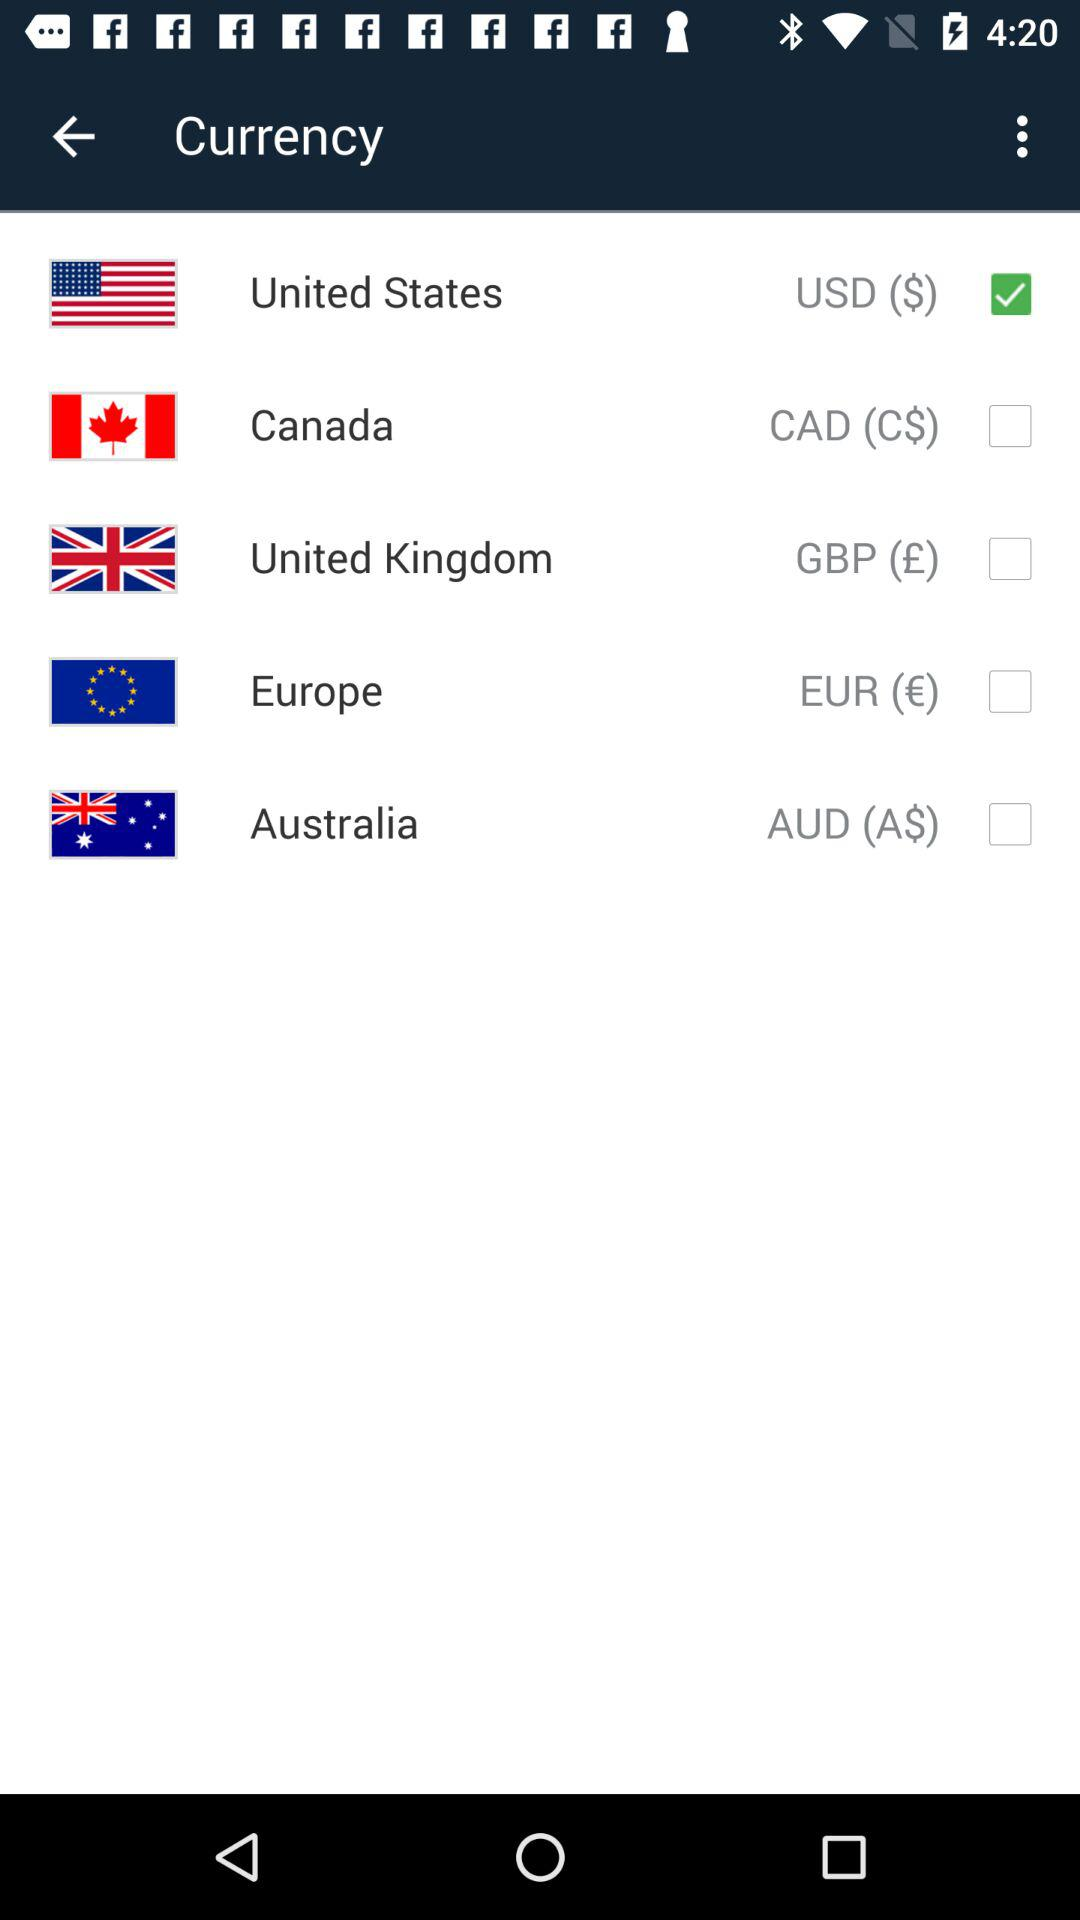Which country's currency is selected? The selected currency is that of the United States. 